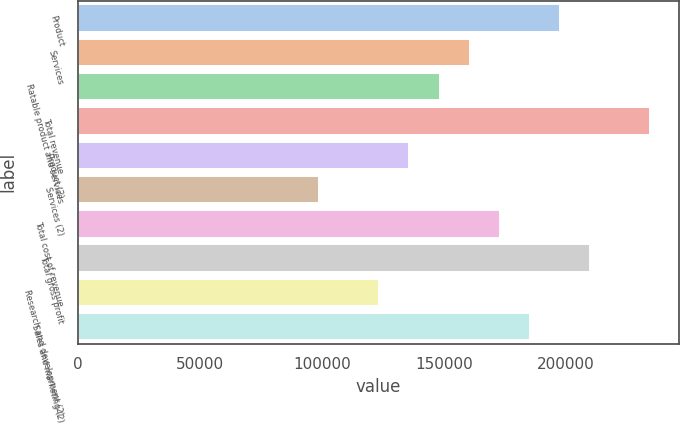<chart> <loc_0><loc_0><loc_500><loc_500><bar_chart><fcel>Product<fcel>Services<fcel>Ratable product and services<fcel>Total revenue<fcel>Product (2)<fcel>Services (2)<fcel>Total cost of revenue<fcel>Total gross profit<fcel>Research and development (2)<fcel>Sales and marketing (2)<nl><fcel>197545<fcel>160506<fcel>148159<fcel>234585<fcel>135813<fcel>98772.8<fcel>172852<fcel>209892<fcel>123466<fcel>185199<nl></chart> 